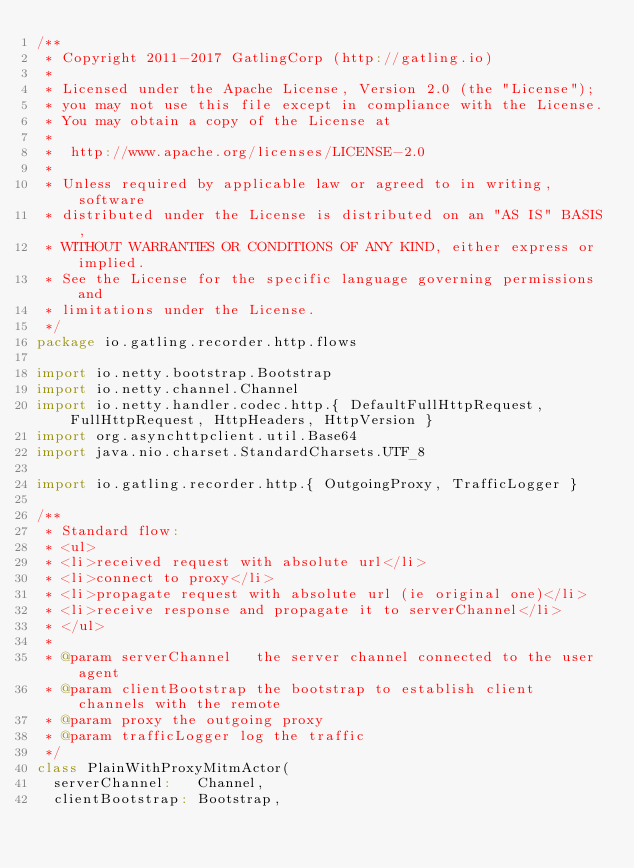Convert code to text. <code><loc_0><loc_0><loc_500><loc_500><_Scala_>/**
 * Copyright 2011-2017 GatlingCorp (http://gatling.io)
 *
 * Licensed under the Apache License, Version 2.0 (the "License");
 * you may not use this file except in compliance with the License.
 * You may obtain a copy of the License at
 *
 *  http://www.apache.org/licenses/LICENSE-2.0
 *
 * Unless required by applicable law or agreed to in writing, software
 * distributed under the License is distributed on an "AS IS" BASIS,
 * WITHOUT WARRANTIES OR CONDITIONS OF ANY KIND, either express or implied.
 * See the License for the specific language governing permissions and
 * limitations under the License.
 */
package io.gatling.recorder.http.flows

import io.netty.bootstrap.Bootstrap
import io.netty.channel.Channel
import io.netty.handler.codec.http.{ DefaultFullHttpRequest, FullHttpRequest, HttpHeaders, HttpVersion }
import org.asynchttpclient.util.Base64
import java.nio.charset.StandardCharsets.UTF_8

import io.gatling.recorder.http.{ OutgoingProxy, TrafficLogger }

/**
 * Standard flow:
 * <ul>
 * <li>received request with absolute url</li>
 * <li>connect to proxy</li>
 * <li>propagate request with absolute url (ie original one)</li>
 * <li>receive response and propagate it to serverChannel</li>
 * </ul>
 *
 * @param serverChannel   the server channel connected to the user agent
 * @param clientBootstrap the bootstrap to establish client channels with the remote
 * @param proxy the outgoing proxy
 * @param trafficLogger log the traffic
 */
class PlainWithProxyMitmActor(
  serverChannel:   Channel,
  clientBootstrap: Bootstrap,</code> 